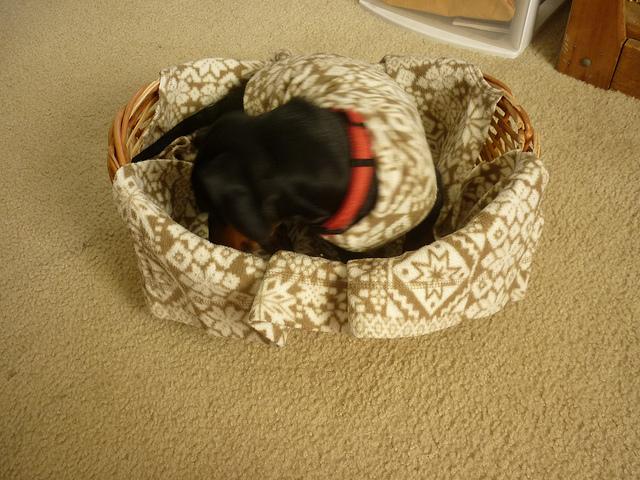What material is that blanket made of?
Keep it brief. Cotton. Is the dog moving?
Write a very short answer. Yes. Where is the collar?
Concise answer only. On dog. 